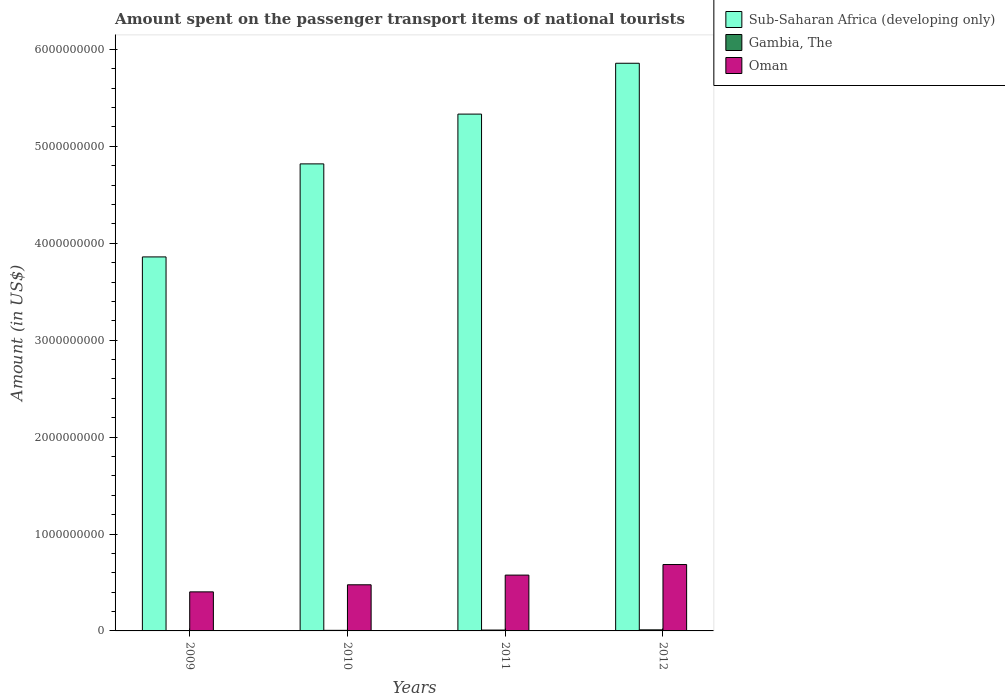Are the number of bars on each tick of the X-axis equal?
Provide a succinct answer. Yes. How many bars are there on the 2nd tick from the left?
Keep it short and to the point. 3. What is the label of the 1st group of bars from the left?
Make the answer very short. 2009. What is the amount spent on the passenger transport items of national tourists in Oman in 2010?
Offer a terse response. 4.76e+08. Across all years, what is the maximum amount spent on the passenger transport items of national tourists in Sub-Saharan Africa (developing only)?
Give a very brief answer. 5.86e+09. Across all years, what is the minimum amount spent on the passenger transport items of national tourists in Sub-Saharan Africa (developing only)?
Your answer should be compact. 3.86e+09. In which year was the amount spent on the passenger transport items of national tourists in Gambia, The maximum?
Your answer should be compact. 2012. In which year was the amount spent on the passenger transport items of national tourists in Oman minimum?
Your answer should be compact. 2009. What is the total amount spent on the passenger transport items of national tourists in Sub-Saharan Africa (developing only) in the graph?
Offer a terse response. 1.99e+1. What is the difference between the amount spent on the passenger transport items of national tourists in Oman in 2009 and that in 2011?
Keep it short and to the point. -1.73e+08. What is the difference between the amount spent on the passenger transport items of national tourists in Gambia, The in 2011 and the amount spent on the passenger transport items of national tourists in Sub-Saharan Africa (developing only) in 2009?
Your answer should be compact. -3.85e+09. What is the average amount spent on the passenger transport items of national tourists in Oman per year?
Provide a short and direct response. 5.35e+08. In the year 2012, what is the difference between the amount spent on the passenger transport items of national tourists in Gambia, The and amount spent on the passenger transport items of national tourists in Sub-Saharan Africa (developing only)?
Keep it short and to the point. -5.85e+09. In how many years, is the amount spent on the passenger transport items of national tourists in Gambia, The greater than 5400000000 US$?
Offer a terse response. 0. What is the ratio of the amount spent on the passenger transport items of national tourists in Gambia, The in 2009 to that in 2011?
Offer a very short reply. 0.11. Is the difference between the amount spent on the passenger transport items of national tourists in Gambia, The in 2009 and 2012 greater than the difference between the amount spent on the passenger transport items of national tourists in Sub-Saharan Africa (developing only) in 2009 and 2012?
Offer a very short reply. Yes. What is the difference between the highest and the second highest amount spent on the passenger transport items of national tourists in Gambia, The?
Ensure brevity in your answer.  2.00e+06. What is the difference between the highest and the lowest amount spent on the passenger transport items of national tourists in Sub-Saharan Africa (developing only)?
Keep it short and to the point. 2.00e+09. In how many years, is the amount spent on the passenger transport items of national tourists in Sub-Saharan Africa (developing only) greater than the average amount spent on the passenger transport items of national tourists in Sub-Saharan Africa (developing only) taken over all years?
Ensure brevity in your answer.  2. What does the 2nd bar from the left in 2011 represents?
Provide a succinct answer. Gambia, The. What does the 1st bar from the right in 2012 represents?
Your response must be concise. Oman. Are all the bars in the graph horizontal?
Your answer should be compact. No. Are the values on the major ticks of Y-axis written in scientific E-notation?
Ensure brevity in your answer.  No. Does the graph contain grids?
Give a very brief answer. No. Where does the legend appear in the graph?
Keep it short and to the point. Top right. What is the title of the graph?
Your response must be concise. Amount spent on the passenger transport items of national tourists. What is the label or title of the Y-axis?
Provide a short and direct response. Amount (in US$). What is the Amount (in US$) of Sub-Saharan Africa (developing only) in 2009?
Keep it short and to the point. 3.86e+09. What is the Amount (in US$) in Gambia, The in 2009?
Your response must be concise. 1.00e+06. What is the Amount (in US$) of Oman in 2009?
Offer a very short reply. 4.03e+08. What is the Amount (in US$) in Sub-Saharan Africa (developing only) in 2010?
Your answer should be very brief. 4.82e+09. What is the Amount (in US$) in Gambia, The in 2010?
Your answer should be compact. 6.00e+06. What is the Amount (in US$) in Oman in 2010?
Keep it short and to the point. 4.76e+08. What is the Amount (in US$) of Sub-Saharan Africa (developing only) in 2011?
Make the answer very short. 5.33e+09. What is the Amount (in US$) of Gambia, The in 2011?
Your response must be concise. 9.00e+06. What is the Amount (in US$) in Oman in 2011?
Provide a short and direct response. 5.76e+08. What is the Amount (in US$) of Sub-Saharan Africa (developing only) in 2012?
Your answer should be very brief. 5.86e+09. What is the Amount (in US$) of Gambia, The in 2012?
Your answer should be very brief. 1.10e+07. What is the Amount (in US$) in Oman in 2012?
Make the answer very short. 6.85e+08. Across all years, what is the maximum Amount (in US$) of Sub-Saharan Africa (developing only)?
Provide a short and direct response. 5.86e+09. Across all years, what is the maximum Amount (in US$) of Gambia, The?
Make the answer very short. 1.10e+07. Across all years, what is the maximum Amount (in US$) in Oman?
Offer a terse response. 6.85e+08. Across all years, what is the minimum Amount (in US$) in Sub-Saharan Africa (developing only)?
Provide a short and direct response. 3.86e+09. Across all years, what is the minimum Amount (in US$) in Oman?
Provide a succinct answer. 4.03e+08. What is the total Amount (in US$) of Sub-Saharan Africa (developing only) in the graph?
Ensure brevity in your answer.  1.99e+1. What is the total Amount (in US$) in Gambia, The in the graph?
Provide a succinct answer. 2.70e+07. What is the total Amount (in US$) in Oman in the graph?
Your answer should be very brief. 2.14e+09. What is the difference between the Amount (in US$) of Sub-Saharan Africa (developing only) in 2009 and that in 2010?
Your response must be concise. -9.60e+08. What is the difference between the Amount (in US$) of Gambia, The in 2009 and that in 2010?
Provide a succinct answer. -5.00e+06. What is the difference between the Amount (in US$) in Oman in 2009 and that in 2010?
Offer a terse response. -7.30e+07. What is the difference between the Amount (in US$) in Sub-Saharan Africa (developing only) in 2009 and that in 2011?
Provide a succinct answer. -1.47e+09. What is the difference between the Amount (in US$) of Gambia, The in 2009 and that in 2011?
Offer a very short reply. -8.00e+06. What is the difference between the Amount (in US$) in Oman in 2009 and that in 2011?
Offer a very short reply. -1.73e+08. What is the difference between the Amount (in US$) of Sub-Saharan Africa (developing only) in 2009 and that in 2012?
Offer a very short reply. -2.00e+09. What is the difference between the Amount (in US$) in Gambia, The in 2009 and that in 2012?
Offer a terse response. -1.00e+07. What is the difference between the Amount (in US$) of Oman in 2009 and that in 2012?
Make the answer very short. -2.82e+08. What is the difference between the Amount (in US$) of Sub-Saharan Africa (developing only) in 2010 and that in 2011?
Your answer should be very brief. -5.14e+08. What is the difference between the Amount (in US$) in Oman in 2010 and that in 2011?
Give a very brief answer. -1.00e+08. What is the difference between the Amount (in US$) in Sub-Saharan Africa (developing only) in 2010 and that in 2012?
Your response must be concise. -1.04e+09. What is the difference between the Amount (in US$) of Gambia, The in 2010 and that in 2012?
Your answer should be compact. -5.00e+06. What is the difference between the Amount (in US$) of Oman in 2010 and that in 2012?
Keep it short and to the point. -2.09e+08. What is the difference between the Amount (in US$) of Sub-Saharan Africa (developing only) in 2011 and that in 2012?
Ensure brevity in your answer.  -5.25e+08. What is the difference between the Amount (in US$) in Gambia, The in 2011 and that in 2012?
Your answer should be very brief. -2.00e+06. What is the difference between the Amount (in US$) of Oman in 2011 and that in 2012?
Provide a succinct answer. -1.09e+08. What is the difference between the Amount (in US$) in Sub-Saharan Africa (developing only) in 2009 and the Amount (in US$) in Gambia, The in 2010?
Your response must be concise. 3.85e+09. What is the difference between the Amount (in US$) of Sub-Saharan Africa (developing only) in 2009 and the Amount (in US$) of Oman in 2010?
Ensure brevity in your answer.  3.38e+09. What is the difference between the Amount (in US$) in Gambia, The in 2009 and the Amount (in US$) in Oman in 2010?
Your response must be concise. -4.75e+08. What is the difference between the Amount (in US$) of Sub-Saharan Africa (developing only) in 2009 and the Amount (in US$) of Gambia, The in 2011?
Make the answer very short. 3.85e+09. What is the difference between the Amount (in US$) of Sub-Saharan Africa (developing only) in 2009 and the Amount (in US$) of Oman in 2011?
Your answer should be compact. 3.28e+09. What is the difference between the Amount (in US$) in Gambia, The in 2009 and the Amount (in US$) in Oman in 2011?
Keep it short and to the point. -5.75e+08. What is the difference between the Amount (in US$) in Sub-Saharan Africa (developing only) in 2009 and the Amount (in US$) in Gambia, The in 2012?
Provide a short and direct response. 3.85e+09. What is the difference between the Amount (in US$) in Sub-Saharan Africa (developing only) in 2009 and the Amount (in US$) in Oman in 2012?
Your answer should be very brief. 3.17e+09. What is the difference between the Amount (in US$) of Gambia, The in 2009 and the Amount (in US$) of Oman in 2012?
Offer a very short reply. -6.84e+08. What is the difference between the Amount (in US$) of Sub-Saharan Africa (developing only) in 2010 and the Amount (in US$) of Gambia, The in 2011?
Offer a terse response. 4.81e+09. What is the difference between the Amount (in US$) in Sub-Saharan Africa (developing only) in 2010 and the Amount (in US$) in Oman in 2011?
Ensure brevity in your answer.  4.24e+09. What is the difference between the Amount (in US$) in Gambia, The in 2010 and the Amount (in US$) in Oman in 2011?
Make the answer very short. -5.70e+08. What is the difference between the Amount (in US$) of Sub-Saharan Africa (developing only) in 2010 and the Amount (in US$) of Gambia, The in 2012?
Give a very brief answer. 4.81e+09. What is the difference between the Amount (in US$) in Sub-Saharan Africa (developing only) in 2010 and the Amount (in US$) in Oman in 2012?
Keep it short and to the point. 4.13e+09. What is the difference between the Amount (in US$) of Gambia, The in 2010 and the Amount (in US$) of Oman in 2012?
Offer a terse response. -6.79e+08. What is the difference between the Amount (in US$) in Sub-Saharan Africa (developing only) in 2011 and the Amount (in US$) in Gambia, The in 2012?
Make the answer very short. 5.32e+09. What is the difference between the Amount (in US$) of Sub-Saharan Africa (developing only) in 2011 and the Amount (in US$) of Oman in 2012?
Your answer should be compact. 4.65e+09. What is the difference between the Amount (in US$) in Gambia, The in 2011 and the Amount (in US$) in Oman in 2012?
Offer a terse response. -6.76e+08. What is the average Amount (in US$) of Sub-Saharan Africa (developing only) per year?
Provide a succinct answer. 4.97e+09. What is the average Amount (in US$) in Gambia, The per year?
Give a very brief answer. 6.75e+06. What is the average Amount (in US$) in Oman per year?
Ensure brevity in your answer.  5.35e+08. In the year 2009, what is the difference between the Amount (in US$) in Sub-Saharan Africa (developing only) and Amount (in US$) in Gambia, The?
Offer a terse response. 3.86e+09. In the year 2009, what is the difference between the Amount (in US$) in Sub-Saharan Africa (developing only) and Amount (in US$) in Oman?
Make the answer very short. 3.46e+09. In the year 2009, what is the difference between the Amount (in US$) of Gambia, The and Amount (in US$) of Oman?
Provide a succinct answer. -4.02e+08. In the year 2010, what is the difference between the Amount (in US$) in Sub-Saharan Africa (developing only) and Amount (in US$) in Gambia, The?
Give a very brief answer. 4.81e+09. In the year 2010, what is the difference between the Amount (in US$) in Sub-Saharan Africa (developing only) and Amount (in US$) in Oman?
Provide a short and direct response. 4.34e+09. In the year 2010, what is the difference between the Amount (in US$) of Gambia, The and Amount (in US$) of Oman?
Offer a terse response. -4.70e+08. In the year 2011, what is the difference between the Amount (in US$) of Sub-Saharan Africa (developing only) and Amount (in US$) of Gambia, The?
Offer a terse response. 5.32e+09. In the year 2011, what is the difference between the Amount (in US$) of Sub-Saharan Africa (developing only) and Amount (in US$) of Oman?
Give a very brief answer. 4.76e+09. In the year 2011, what is the difference between the Amount (in US$) of Gambia, The and Amount (in US$) of Oman?
Ensure brevity in your answer.  -5.67e+08. In the year 2012, what is the difference between the Amount (in US$) in Sub-Saharan Africa (developing only) and Amount (in US$) in Gambia, The?
Your answer should be very brief. 5.85e+09. In the year 2012, what is the difference between the Amount (in US$) in Sub-Saharan Africa (developing only) and Amount (in US$) in Oman?
Your answer should be compact. 5.17e+09. In the year 2012, what is the difference between the Amount (in US$) of Gambia, The and Amount (in US$) of Oman?
Your response must be concise. -6.74e+08. What is the ratio of the Amount (in US$) in Sub-Saharan Africa (developing only) in 2009 to that in 2010?
Ensure brevity in your answer.  0.8. What is the ratio of the Amount (in US$) of Gambia, The in 2009 to that in 2010?
Provide a succinct answer. 0.17. What is the ratio of the Amount (in US$) of Oman in 2009 to that in 2010?
Keep it short and to the point. 0.85. What is the ratio of the Amount (in US$) in Sub-Saharan Africa (developing only) in 2009 to that in 2011?
Provide a short and direct response. 0.72. What is the ratio of the Amount (in US$) in Oman in 2009 to that in 2011?
Make the answer very short. 0.7. What is the ratio of the Amount (in US$) in Sub-Saharan Africa (developing only) in 2009 to that in 2012?
Offer a terse response. 0.66. What is the ratio of the Amount (in US$) of Gambia, The in 2009 to that in 2012?
Your answer should be compact. 0.09. What is the ratio of the Amount (in US$) of Oman in 2009 to that in 2012?
Provide a succinct answer. 0.59. What is the ratio of the Amount (in US$) of Sub-Saharan Africa (developing only) in 2010 to that in 2011?
Give a very brief answer. 0.9. What is the ratio of the Amount (in US$) of Oman in 2010 to that in 2011?
Make the answer very short. 0.83. What is the ratio of the Amount (in US$) of Sub-Saharan Africa (developing only) in 2010 to that in 2012?
Offer a terse response. 0.82. What is the ratio of the Amount (in US$) in Gambia, The in 2010 to that in 2012?
Ensure brevity in your answer.  0.55. What is the ratio of the Amount (in US$) of Oman in 2010 to that in 2012?
Provide a succinct answer. 0.69. What is the ratio of the Amount (in US$) in Sub-Saharan Africa (developing only) in 2011 to that in 2012?
Provide a succinct answer. 0.91. What is the ratio of the Amount (in US$) of Gambia, The in 2011 to that in 2012?
Make the answer very short. 0.82. What is the ratio of the Amount (in US$) in Oman in 2011 to that in 2012?
Give a very brief answer. 0.84. What is the difference between the highest and the second highest Amount (in US$) of Sub-Saharan Africa (developing only)?
Your answer should be very brief. 5.25e+08. What is the difference between the highest and the second highest Amount (in US$) in Oman?
Ensure brevity in your answer.  1.09e+08. What is the difference between the highest and the lowest Amount (in US$) in Sub-Saharan Africa (developing only)?
Keep it short and to the point. 2.00e+09. What is the difference between the highest and the lowest Amount (in US$) in Oman?
Make the answer very short. 2.82e+08. 